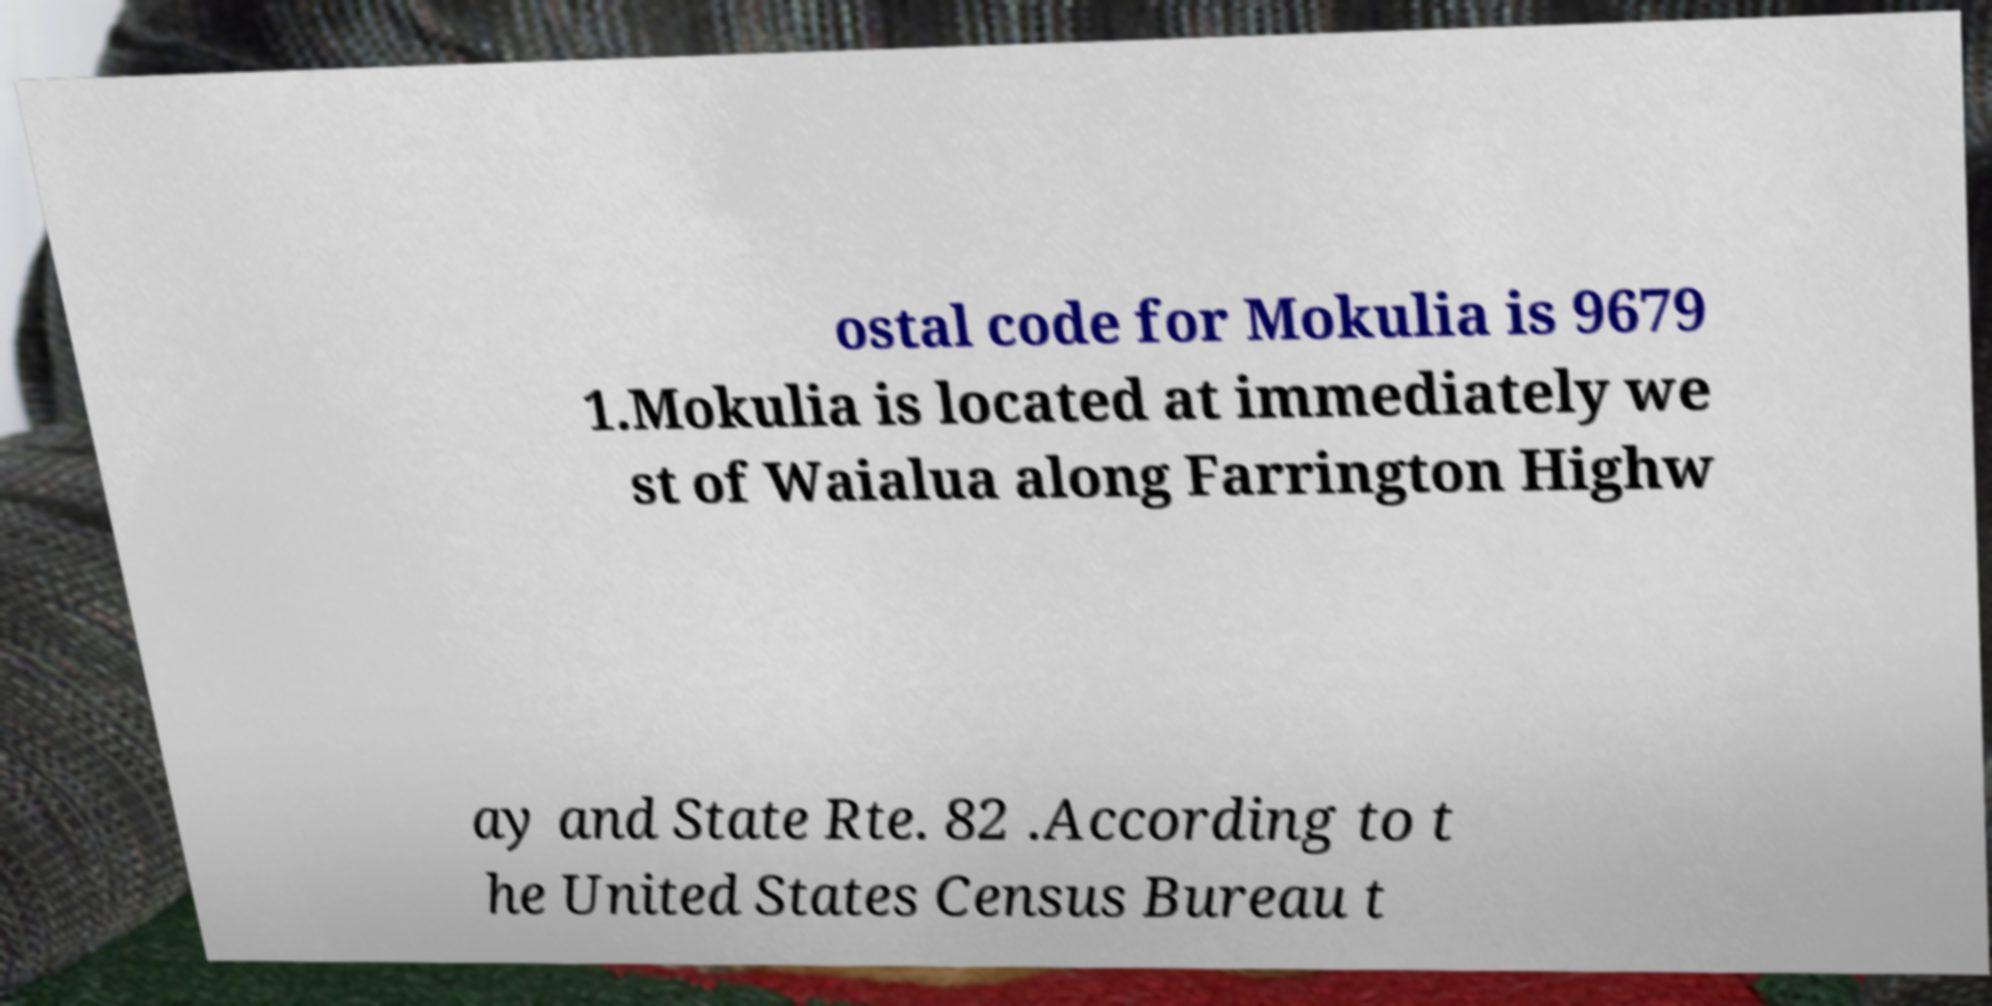I need the written content from this picture converted into text. Can you do that? ostal code for Mokulia is 9679 1.Mokulia is located at immediately we st of Waialua along Farrington Highw ay and State Rte. 82 .According to t he United States Census Bureau t 